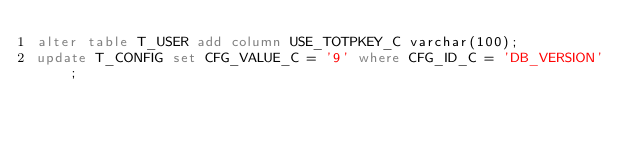<code> <loc_0><loc_0><loc_500><loc_500><_SQL_>alter table T_USER add column USE_TOTPKEY_C varchar(100);
update T_CONFIG set CFG_VALUE_C = '9' where CFG_ID_C = 'DB_VERSION';
</code> 